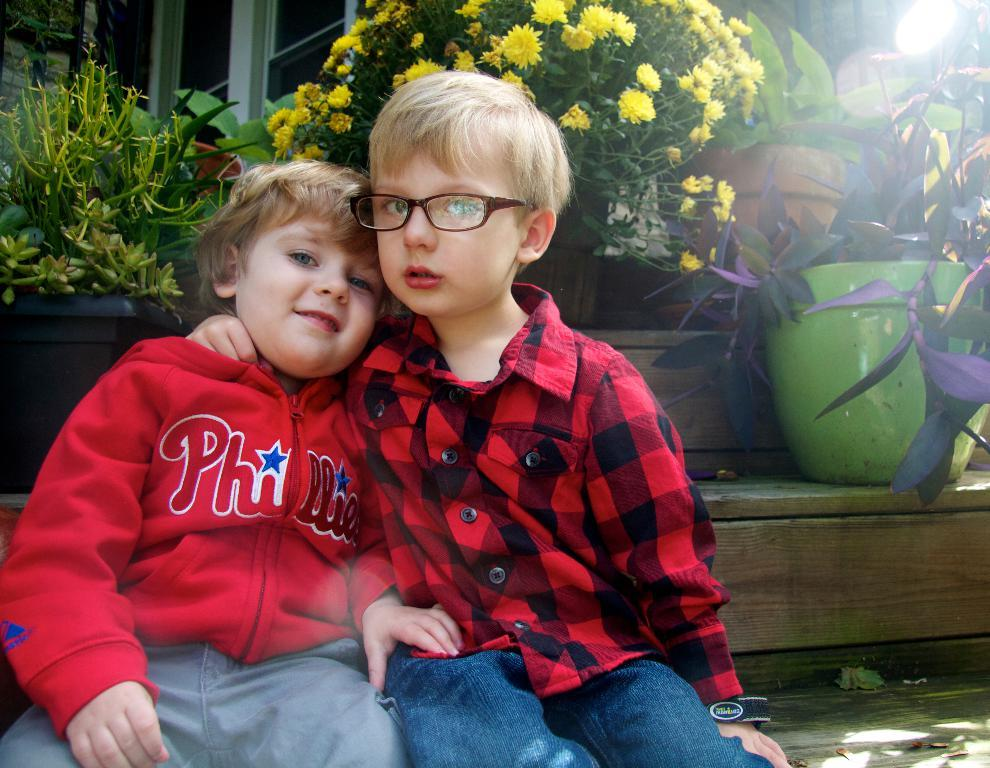Who is present in the image? There are kids in the image. What are the kids doing in the image? The kids are sitting on the stairs. What can be seen in the background of the image? There are different kinds of plants in the background. How are the plants arranged in the image? The plants are in pots. What type of haircut is the kid on the left getting in the image? There is no haircut being performed in the image; the kids are sitting on the stairs. What kind of treatment is the kid on the right receiving in the image? There is no treatment being administered in the image; the kids are sitting on the stairs. 